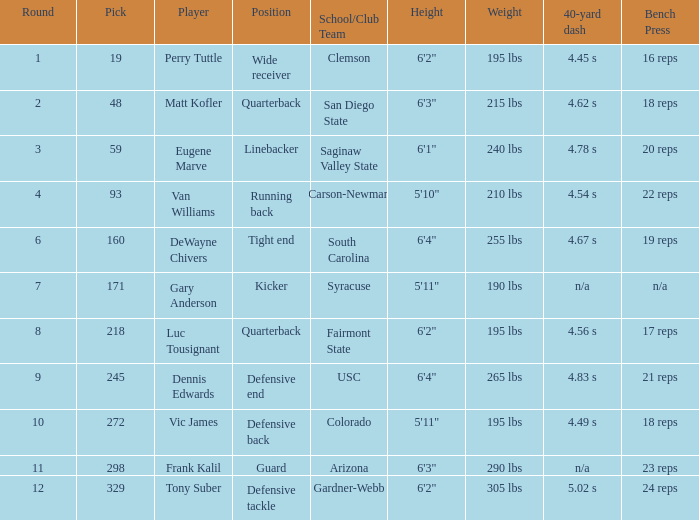Which Round has a School/Club Team of arizona, and a Pick smaller than 298? None. 